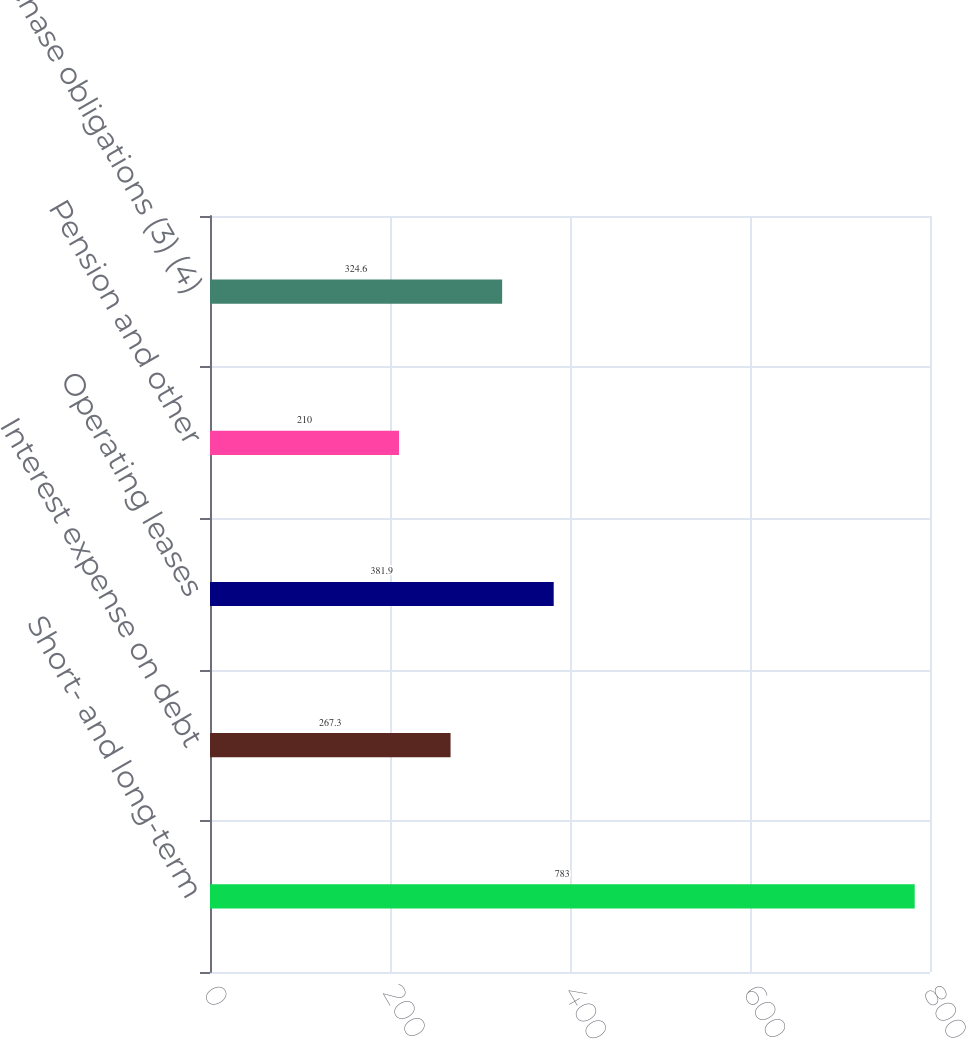Convert chart. <chart><loc_0><loc_0><loc_500><loc_500><bar_chart><fcel>Short- and long-term<fcel>Interest expense on debt<fcel>Operating leases<fcel>Pension and other<fcel>Purchase obligations (3) (4)<nl><fcel>783<fcel>267.3<fcel>381.9<fcel>210<fcel>324.6<nl></chart> 